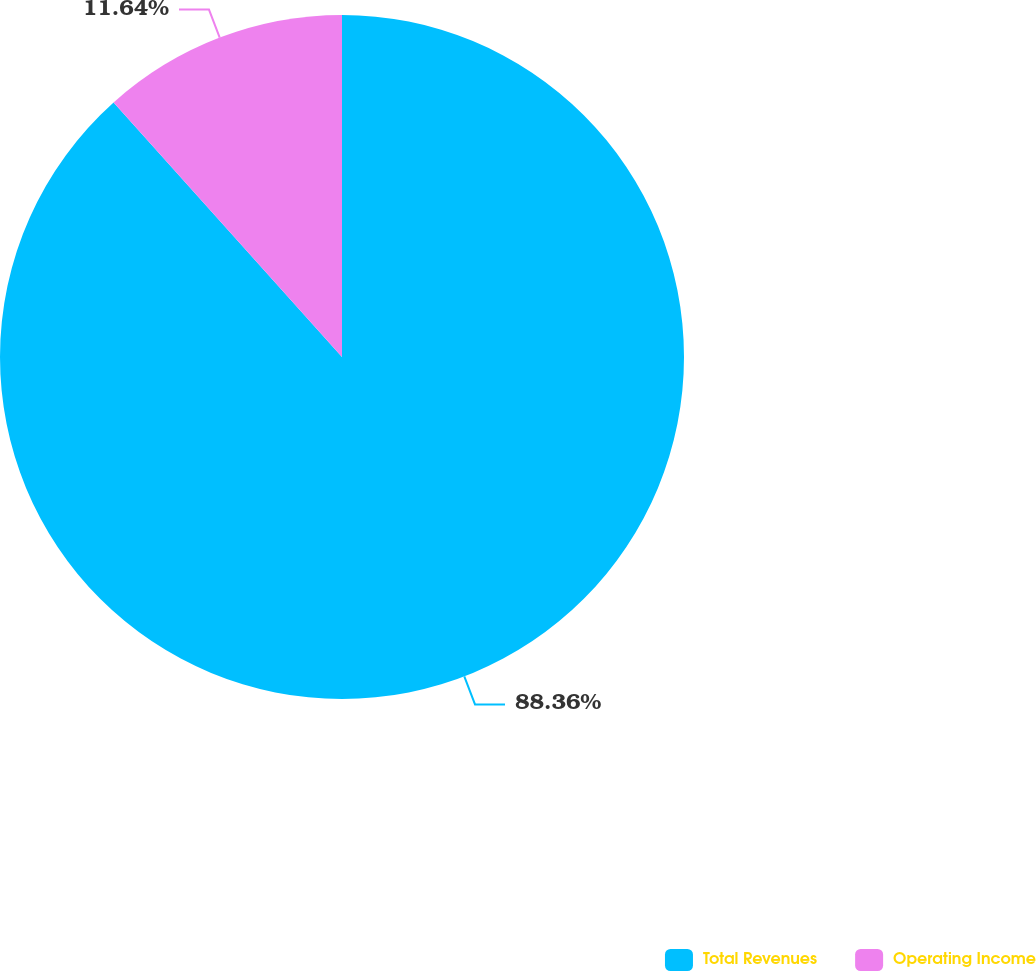Convert chart. <chart><loc_0><loc_0><loc_500><loc_500><pie_chart><fcel>Total Revenues<fcel>Operating Income<nl><fcel>88.36%<fcel>11.64%<nl></chart> 